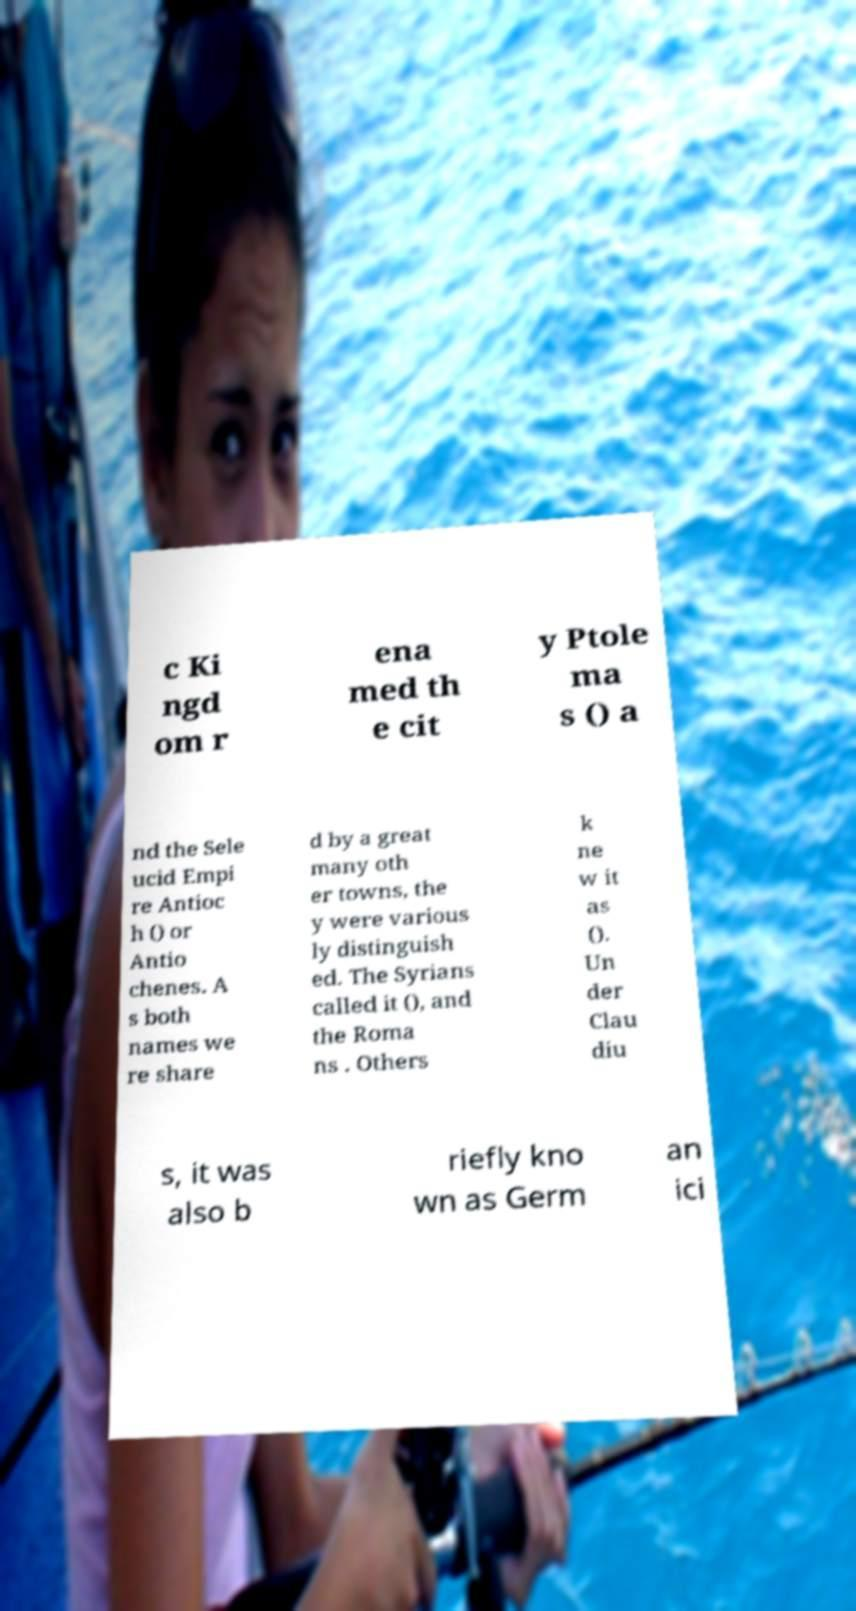Can you accurately transcribe the text from the provided image for me? c Ki ngd om r ena med th e cit y Ptole ma s () a nd the Sele ucid Empi re Antioc h () or Antio chenes. A s both names we re share d by a great many oth er towns, the y were various ly distinguish ed. The Syrians called it (), and the Roma ns . Others k ne w it as (). Un der Clau diu s, it was also b riefly kno wn as Germ an ici 